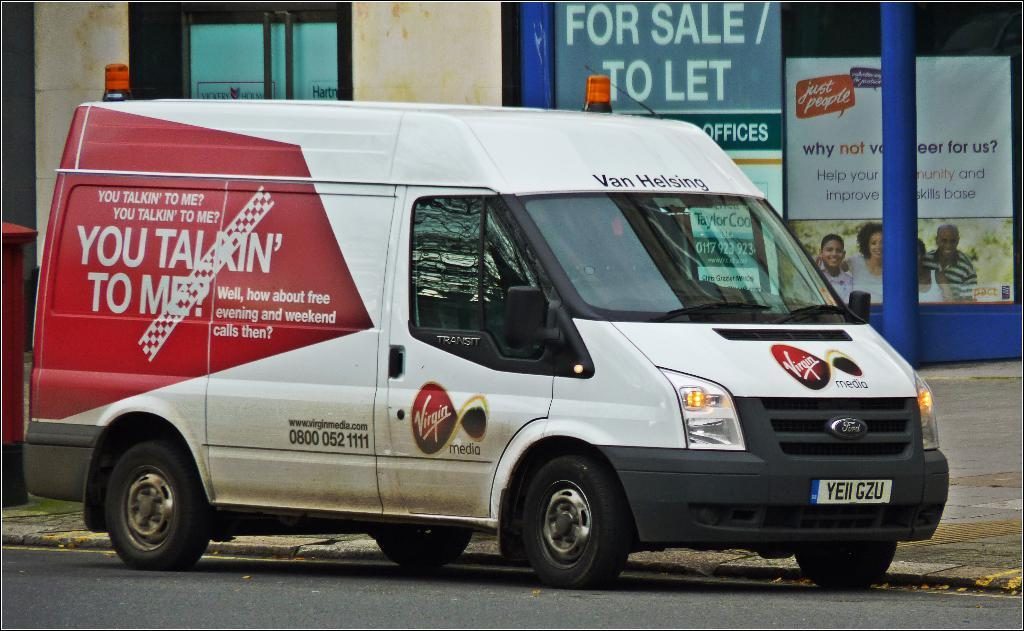What is the main subject in the center of the image? There is a vehicle in the center of the image. What is located at the bottom of the image? There is a road at the bottom of the image. What can be seen in the background of the image? There are boards, a pole, and a wall in the background of the image. Where is the post box located in the image? The post box is on the left side of the image. What type of calculator is being used by the parent in the image? There is no calculator or parent present in the image. What letters are being written by the person in the image? There is no person writing letters in the image. 